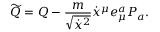Convert formula to latex. <formula><loc_0><loc_0><loc_500><loc_500>\widetilde { Q } = Q - { \frac { m } { \sqrt { \dot { x } ^ { 2 } } } } \dot { x } ^ { \mu } e _ { \mu } ^ { a } P _ { a } .</formula> 